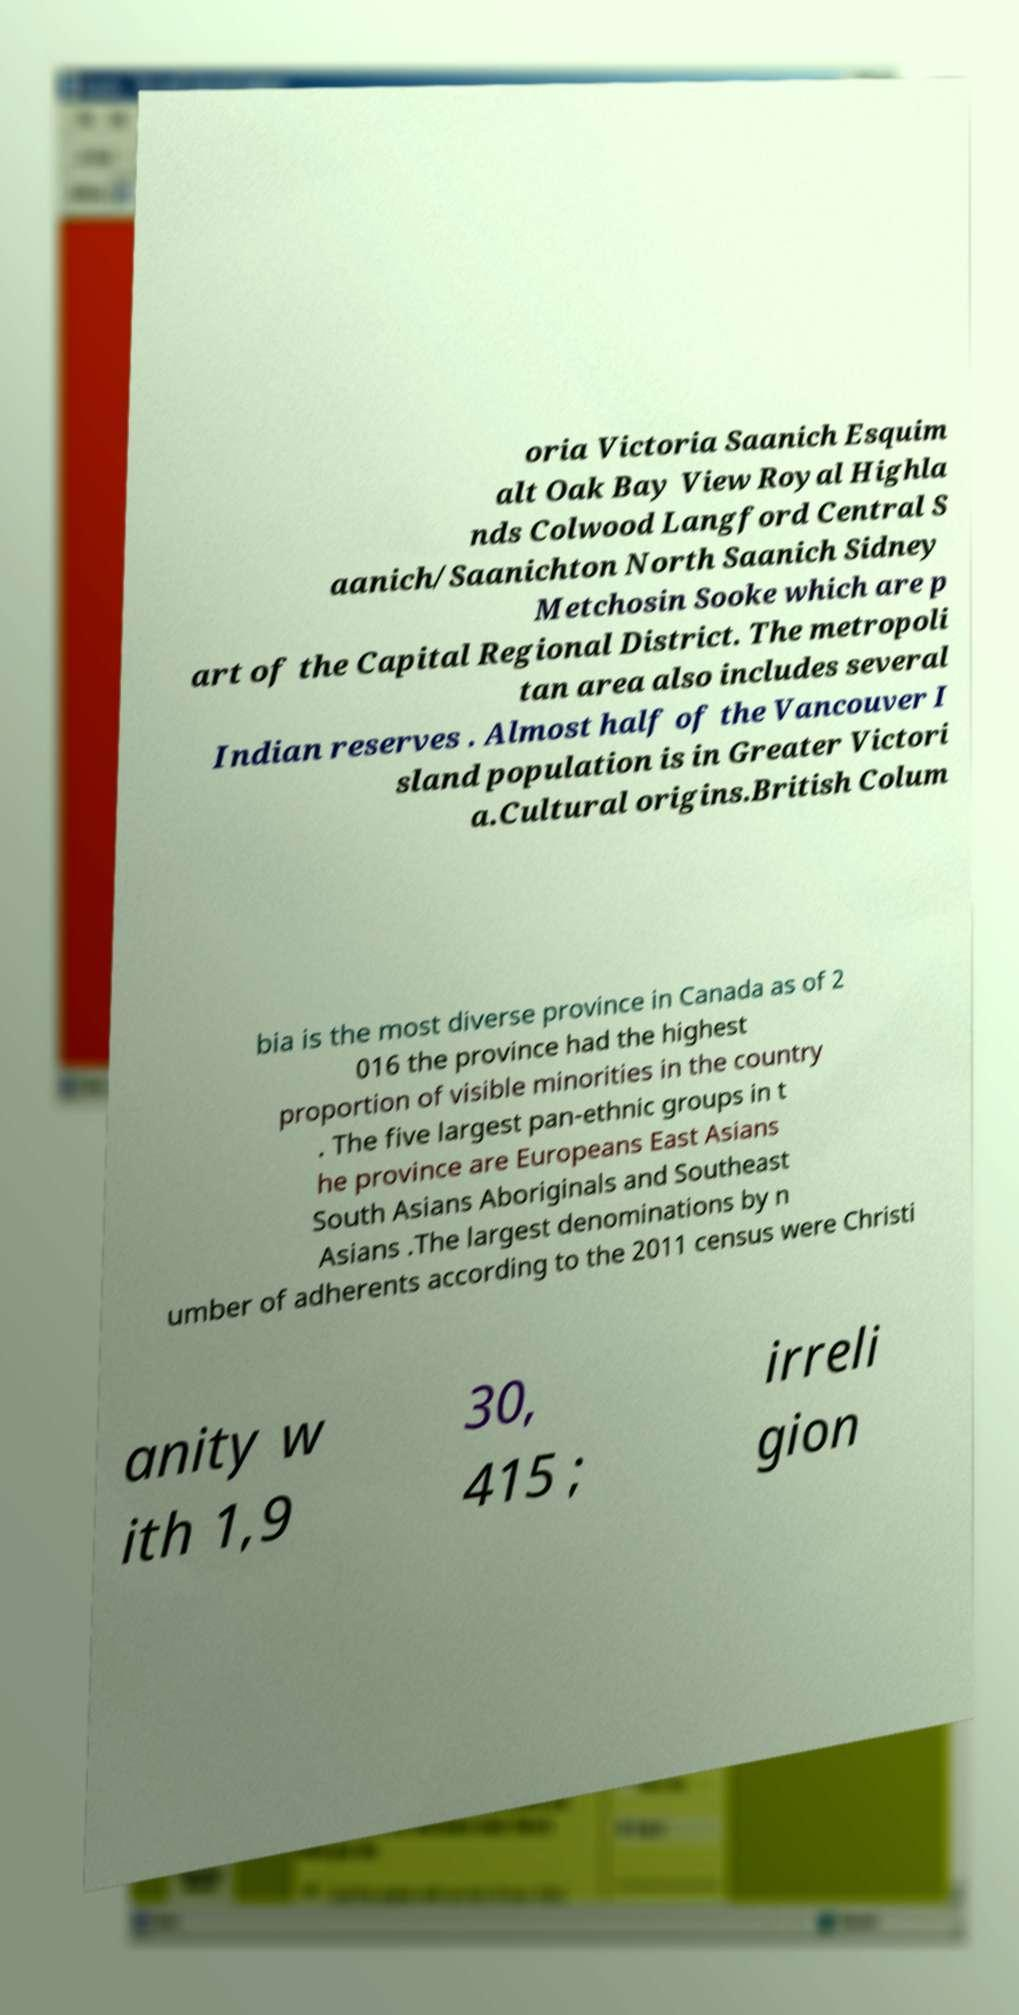I need the written content from this picture converted into text. Can you do that? oria Victoria Saanich Esquim alt Oak Bay View Royal Highla nds Colwood Langford Central S aanich/Saanichton North Saanich Sidney Metchosin Sooke which are p art of the Capital Regional District. The metropoli tan area also includes several Indian reserves . Almost half of the Vancouver I sland population is in Greater Victori a.Cultural origins.British Colum bia is the most diverse province in Canada as of 2 016 the province had the highest proportion of visible minorities in the country . The five largest pan-ethnic groups in t he province are Europeans East Asians South Asians Aboriginals and Southeast Asians .The largest denominations by n umber of adherents according to the 2011 census were Christi anity w ith 1,9 30, 415 ; irreli gion 